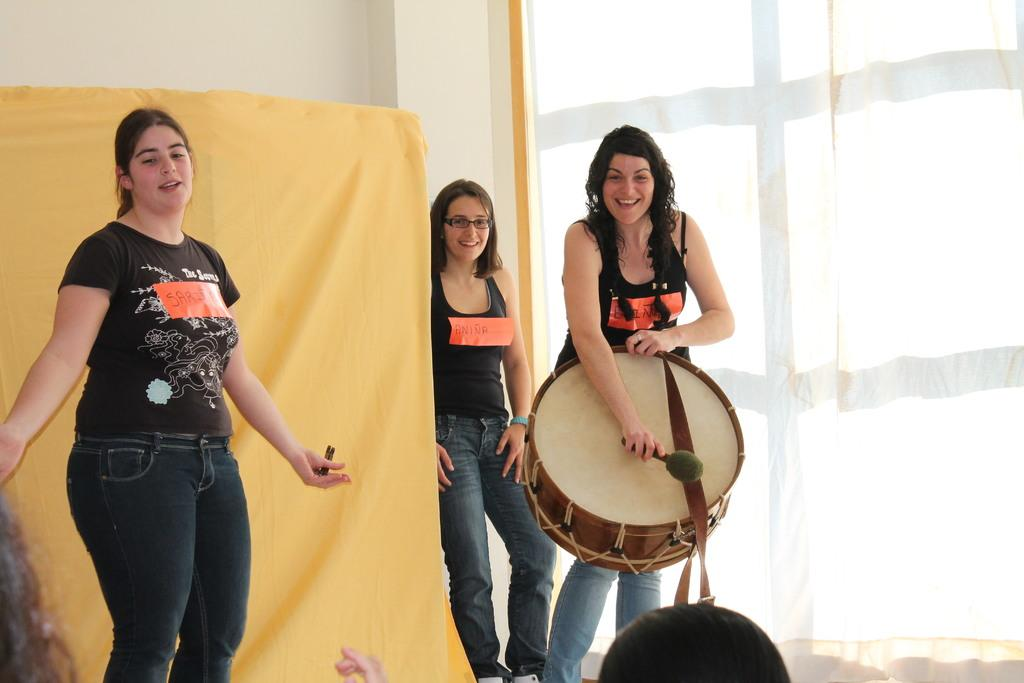How many women are in the image? There are three women in the image. What are the women doing in the image? The women are standing and smiling. Can you describe what one of the women is holding? One woman is holding a drum and playing it. What can be seen hanging in the image? There are two objects that look like cloth hanging, one yellow and one white. Who is the owner of the drum in the image? The image does not provide information about the ownership of the drum, so it cannot be determined. What process is being depicted in the image? The image shows three women standing and smiling, with one playing a drum. There is no specific process being depicted. 